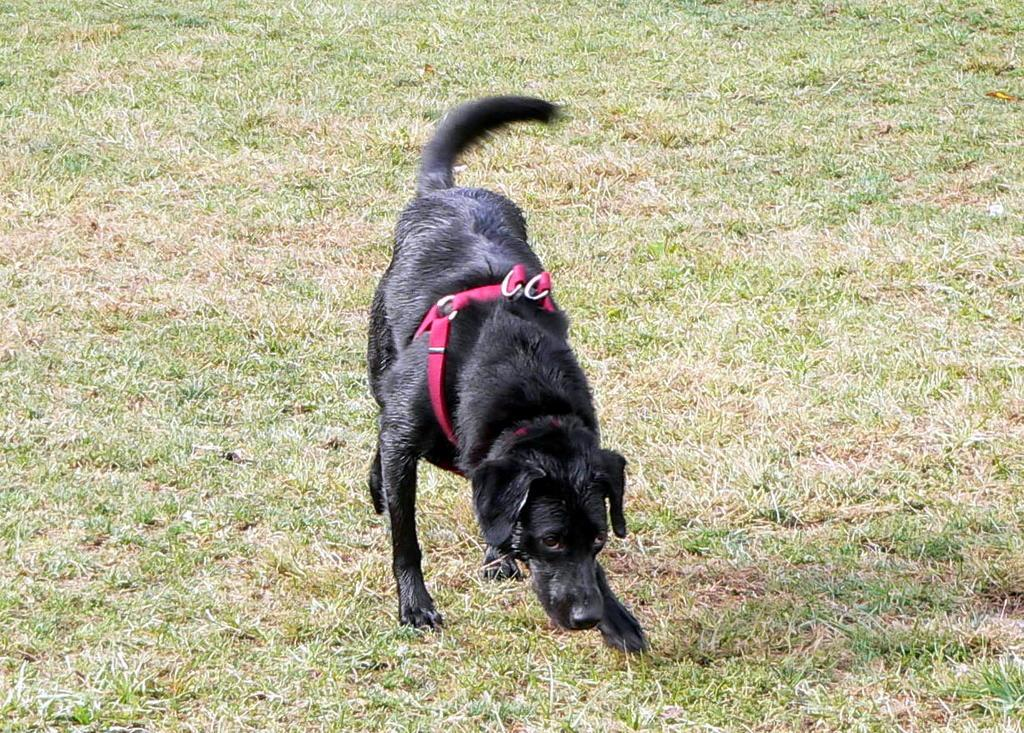What type of animal is in the image? There is a black dog in the image. What is the ground made of in the image? There is green grass at the bottom of the image. What accessory does the dog have in the image? The dog has a red belt tied to it. Is the grass in the image low or high? The facts provided do not specify the height of the grass, so it cannot be determined whether it is low or high. 